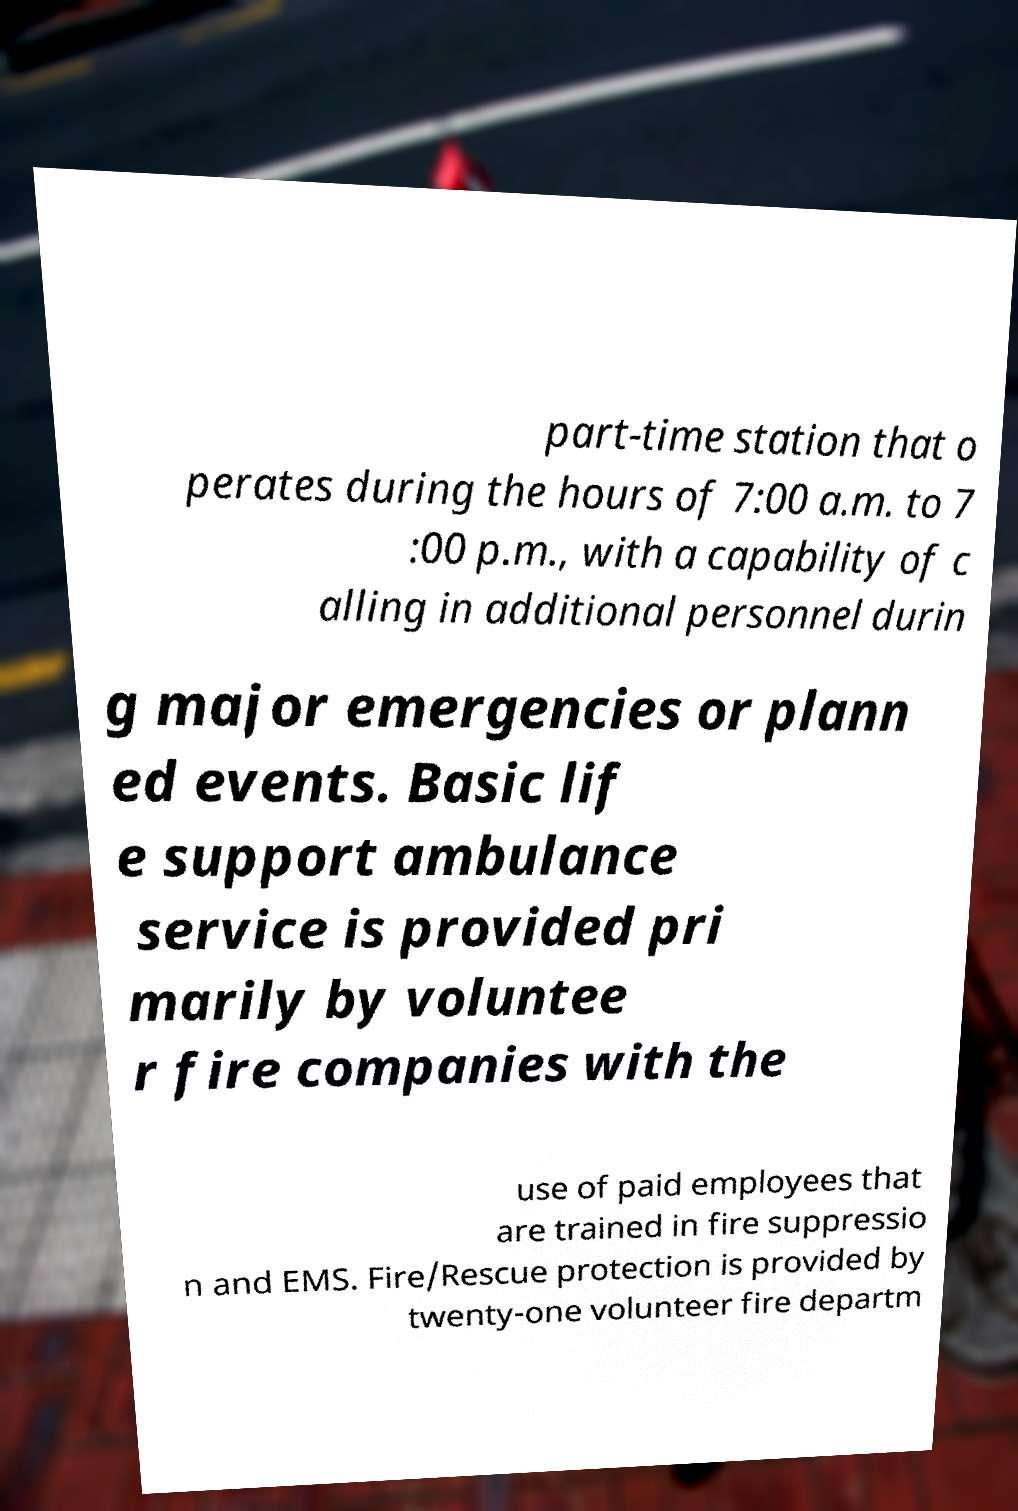Please identify and transcribe the text found in this image. part-time station that o perates during the hours of 7:00 a.m. to 7 :00 p.m., with a capability of c alling in additional personnel durin g major emergencies or plann ed events. Basic lif e support ambulance service is provided pri marily by voluntee r fire companies with the use of paid employees that are trained in fire suppressio n and EMS. Fire/Rescue protection is provided by twenty-one volunteer fire departm 